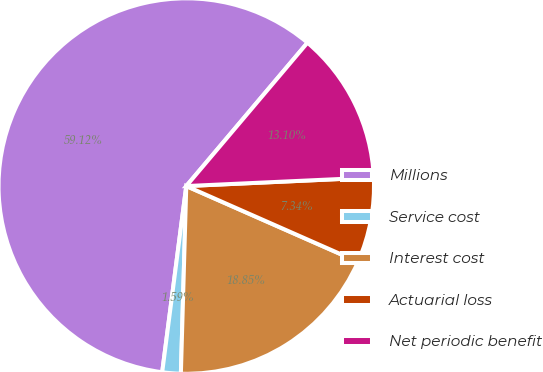Convert chart to OTSL. <chart><loc_0><loc_0><loc_500><loc_500><pie_chart><fcel>Millions<fcel>Service cost<fcel>Interest cost<fcel>Actuarial loss<fcel>Net periodic benefit<nl><fcel>59.13%<fcel>1.59%<fcel>18.85%<fcel>7.34%<fcel>13.1%<nl></chart> 